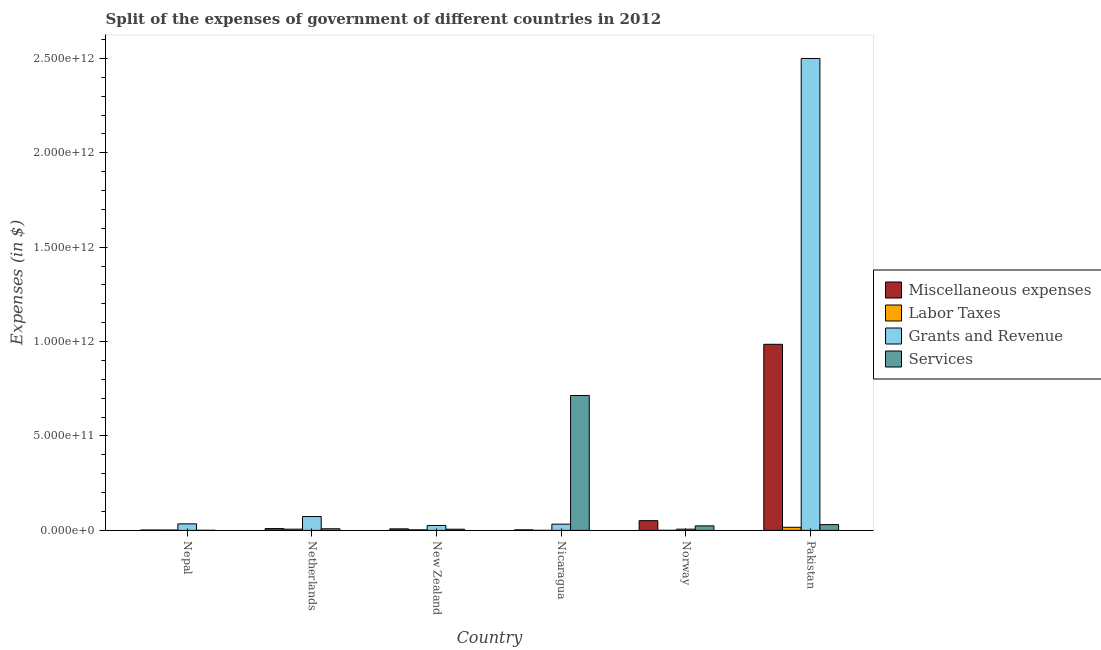How many different coloured bars are there?
Your response must be concise. 4. How many groups of bars are there?
Offer a very short reply. 6. How many bars are there on the 5th tick from the right?
Your response must be concise. 4. What is the label of the 6th group of bars from the left?
Provide a short and direct response. Pakistan. In how many cases, is the number of bars for a given country not equal to the number of legend labels?
Your response must be concise. 0. What is the amount spent on miscellaneous expenses in New Zealand?
Your answer should be very brief. 8.11e+09. Across all countries, what is the maximum amount spent on services?
Your answer should be very brief. 7.14e+11. Across all countries, what is the minimum amount spent on services?
Keep it short and to the point. 4.14e+08. In which country was the amount spent on grants and revenue maximum?
Offer a terse response. Pakistan. In which country was the amount spent on labor taxes minimum?
Keep it short and to the point. Nicaragua. What is the total amount spent on services in the graph?
Offer a very short reply. 7.84e+11. What is the difference between the amount spent on labor taxes in Netherlands and that in New Zealand?
Make the answer very short. 3.64e+09. What is the difference between the amount spent on grants and revenue in Nicaragua and the amount spent on labor taxes in Pakistan?
Your answer should be compact. 1.66e+1. What is the average amount spent on grants and revenue per country?
Offer a very short reply. 4.45e+11. What is the difference between the amount spent on labor taxes and amount spent on miscellaneous expenses in Nepal?
Offer a very short reply. -4.39e+07. What is the ratio of the amount spent on labor taxes in Nepal to that in Norway?
Keep it short and to the point. 7.44. Is the amount spent on labor taxes in New Zealand less than that in Pakistan?
Make the answer very short. Yes. What is the difference between the highest and the second highest amount spent on grants and revenue?
Offer a terse response. 2.43e+12. What is the difference between the highest and the lowest amount spent on miscellaneous expenses?
Make the answer very short. 9.84e+11. In how many countries, is the amount spent on miscellaneous expenses greater than the average amount spent on miscellaneous expenses taken over all countries?
Your answer should be very brief. 1. What does the 2nd bar from the left in New Zealand represents?
Give a very brief answer. Labor Taxes. What does the 2nd bar from the right in Netherlands represents?
Provide a succinct answer. Grants and Revenue. Is it the case that in every country, the sum of the amount spent on miscellaneous expenses and amount spent on labor taxes is greater than the amount spent on grants and revenue?
Offer a very short reply. No. Are all the bars in the graph horizontal?
Provide a succinct answer. No. How many countries are there in the graph?
Give a very brief answer. 6. What is the difference between two consecutive major ticks on the Y-axis?
Your response must be concise. 5.00e+11. Are the values on the major ticks of Y-axis written in scientific E-notation?
Ensure brevity in your answer.  Yes. Does the graph contain grids?
Offer a very short reply. No. Where does the legend appear in the graph?
Provide a short and direct response. Center right. How many legend labels are there?
Your response must be concise. 4. How are the legend labels stacked?
Ensure brevity in your answer.  Vertical. What is the title of the graph?
Make the answer very short. Split of the expenses of government of different countries in 2012. Does "Social Assistance" appear as one of the legend labels in the graph?
Ensure brevity in your answer.  No. What is the label or title of the X-axis?
Provide a succinct answer. Country. What is the label or title of the Y-axis?
Your answer should be compact. Expenses (in $). What is the Expenses (in $) in Miscellaneous expenses in Nepal?
Your answer should be very brief. 2.00e+09. What is the Expenses (in $) in Labor Taxes in Nepal?
Offer a terse response. 1.95e+09. What is the Expenses (in $) of Grants and Revenue in Nepal?
Offer a terse response. 3.46e+1. What is the Expenses (in $) of Services in Nepal?
Your answer should be compact. 4.14e+08. What is the Expenses (in $) of Miscellaneous expenses in Netherlands?
Ensure brevity in your answer.  9.59e+09. What is the Expenses (in $) of Labor Taxes in Netherlands?
Provide a succinct answer. 6.47e+09. What is the Expenses (in $) of Grants and Revenue in Netherlands?
Keep it short and to the point. 7.33e+1. What is the Expenses (in $) of Services in Netherlands?
Give a very brief answer. 8.57e+09. What is the Expenses (in $) of Miscellaneous expenses in New Zealand?
Keep it short and to the point. 8.11e+09. What is the Expenses (in $) in Labor Taxes in New Zealand?
Offer a terse response. 2.83e+09. What is the Expenses (in $) in Grants and Revenue in New Zealand?
Ensure brevity in your answer.  2.60e+1. What is the Expenses (in $) of Services in New Zealand?
Your response must be concise. 6.25e+09. What is the Expenses (in $) of Miscellaneous expenses in Nicaragua?
Offer a terse response. 2.83e+09. What is the Expenses (in $) in Labor Taxes in Nicaragua?
Your answer should be compact. 1.50e+08. What is the Expenses (in $) of Grants and Revenue in Nicaragua?
Your answer should be very brief. 3.30e+1. What is the Expenses (in $) of Services in Nicaragua?
Provide a succinct answer. 7.14e+11. What is the Expenses (in $) in Miscellaneous expenses in Norway?
Your answer should be compact. 5.16e+1. What is the Expenses (in $) of Labor Taxes in Norway?
Offer a terse response. 2.63e+08. What is the Expenses (in $) of Grants and Revenue in Norway?
Keep it short and to the point. 6.53e+09. What is the Expenses (in $) in Services in Norway?
Ensure brevity in your answer.  2.38e+1. What is the Expenses (in $) in Miscellaneous expenses in Pakistan?
Your answer should be very brief. 9.86e+11. What is the Expenses (in $) of Labor Taxes in Pakistan?
Offer a very short reply. 1.64e+1. What is the Expenses (in $) of Grants and Revenue in Pakistan?
Give a very brief answer. 2.50e+12. What is the Expenses (in $) in Services in Pakistan?
Ensure brevity in your answer.  3.05e+1. Across all countries, what is the maximum Expenses (in $) in Miscellaneous expenses?
Offer a terse response. 9.86e+11. Across all countries, what is the maximum Expenses (in $) of Labor Taxes?
Offer a very short reply. 1.64e+1. Across all countries, what is the maximum Expenses (in $) in Grants and Revenue?
Make the answer very short. 2.50e+12. Across all countries, what is the maximum Expenses (in $) of Services?
Your answer should be very brief. 7.14e+11. Across all countries, what is the minimum Expenses (in $) of Miscellaneous expenses?
Your answer should be very brief. 2.00e+09. Across all countries, what is the minimum Expenses (in $) of Labor Taxes?
Offer a very short reply. 1.50e+08. Across all countries, what is the minimum Expenses (in $) of Grants and Revenue?
Give a very brief answer. 6.53e+09. Across all countries, what is the minimum Expenses (in $) in Services?
Make the answer very short. 4.14e+08. What is the total Expenses (in $) in Miscellaneous expenses in the graph?
Provide a succinct answer. 1.06e+12. What is the total Expenses (in $) in Labor Taxes in the graph?
Ensure brevity in your answer.  2.81e+1. What is the total Expenses (in $) in Grants and Revenue in the graph?
Offer a terse response. 2.67e+12. What is the total Expenses (in $) in Services in the graph?
Keep it short and to the point. 7.84e+11. What is the difference between the Expenses (in $) in Miscellaneous expenses in Nepal and that in Netherlands?
Your answer should be very brief. -7.59e+09. What is the difference between the Expenses (in $) in Labor Taxes in Nepal and that in Netherlands?
Offer a terse response. -4.51e+09. What is the difference between the Expenses (in $) of Grants and Revenue in Nepal and that in Netherlands?
Provide a short and direct response. -3.88e+1. What is the difference between the Expenses (in $) in Services in Nepal and that in Netherlands?
Offer a terse response. -8.16e+09. What is the difference between the Expenses (in $) in Miscellaneous expenses in Nepal and that in New Zealand?
Offer a very short reply. -6.11e+09. What is the difference between the Expenses (in $) in Labor Taxes in Nepal and that in New Zealand?
Provide a succinct answer. -8.75e+08. What is the difference between the Expenses (in $) in Grants and Revenue in Nepal and that in New Zealand?
Ensure brevity in your answer.  8.54e+09. What is the difference between the Expenses (in $) in Services in Nepal and that in New Zealand?
Your answer should be very brief. -5.84e+09. What is the difference between the Expenses (in $) in Miscellaneous expenses in Nepal and that in Nicaragua?
Give a very brief answer. -8.30e+08. What is the difference between the Expenses (in $) in Labor Taxes in Nepal and that in Nicaragua?
Offer a terse response. 1.80e+09. What is the difference between the Expenses (in $) of Grants and Revenue in Nepal and that in Nicaragua?
Your answer should be very brief. 1.53e+09. What is the difference between the Expenses (in $) in Services in Nepal and that in Nicaragua?
Provide a short and direct response. -7.14e+11. What is the difference between the Expenses (in $) in Miscellaneous expenses in Nepal and that in Norway?
Provide a succinct answer. -4.96e+1. What is the difference between the Expenses (in $) in Labor Taxes in Nepal and that in Norway?
Make the answer very short. 1.69e+09. What is the difference between the Expenses (in $) in Grants and Revenue in Nepal and that in Norway?
Ensure brevity in your answer.  2.80e+1. What is the difference between the Expenses (in $) of Services in Nepal and that in Norway?
Keep it short and to the point. -2.34e+1. What is the difference between the Expenses (in $) in Miscellaneous expenses in Nepal and that in Pakistan?
Provide a succinct answer. -9.84e+11. What is the difference between the Expenses (in $) in Labor Taxes in Nepal and that in Pakistan?
Offer a very short reply. -1.45e+1. What is the difference between the Expenses (in $) of Grants and Revenue in Nepal and that in Pakistan?
Ensure brevity in your answer.  -2.46e+12. What is the difference between the Expenses (in $) in Services in Nepal and that in Pakistan?
Provide a succinct answer. -3.01e+1. What is the difference between the Expenses (in $) of Miscellaneous expenses in Netherlands and that in New Zealand?
Give a very brief answer. 1.48e+09. What is the difference between the Expenses (in $) of Labor Taxes in Netherlands and that in New Zealand?
Ensure brevity in your answer.  3.64e+09. What is the difference between the Expenses (in $) of Grants and Revenue in Netherlands and that in New Zealand?
Offer a terse response. 4.73e+1. What is the difference between the Expenses (in $) in Services in Netherlands and that in New Zealand?
Offer a very short reply. 2.32e+09. What is the difference between the Expenses (in $) in Miscellaneous expenses in Netherlands and that in Nicaragua?
Provide a succinct answer. 6.76e+09. What is the difference between the Expenses (in $) in Labor Taxes in Netherlands and that in Nicaragua?
Keep it short and to the point. 6.32e+09. What is the difference between the Expenses (in $) of Grants and Revenue in Netherlands and that in Nicaragua?
Give a very brief answer. 4.03e+1. What is the difference between the Expenses (in $) of Services in Netherlands and that in Nicaragua?
Keep it short and to the point. -7.06e+11. What is the difference between the Expenses (in $) in Miscellaneous expenses in Netherlands and that in Norway?
Ensure brevity in your answer.  -4.20e+1. What is the difference between the Expenses (in $) of Labor Taxes in Netherlands and that in Norway?
Give a very brief answer. 6.20e+09. What is the difference between the Expenses (in $) in Grants and Revenue in Netherlands and that in Norway?
Give a very brief answer. 6.68e+1. What is the difference between the Expenses (in $) in Services in Netherlands and that in Norway?
Provide a succinct answer. -1.53e+1. What is the difference between the Expenses (in $) of Miscellaneous expenses in Netherlands and that in Pakistan?
Your answer should be compact. -9.76e+11. What is the difference between the Expenses (in $) of Labor Taxes in Netherlands and that in Pakistan?
Provide a succinct answer. -9.98e+09. What is the difference between the Expenses (in $) of Grants and Revenue in Netherlands and that in Pakistan?
Your response must be concise. -2.43e+12. What is the difference between the Expenses (in $) of Services in Netherlands and that in Pakistan?
Your response must be concise. -2.19e+1. What is the difference between the Expenses (in $) in Miscellaneous expenses in New Zealand and that in Nicaragua?
Offer a terse response. 5.28e+09. What is the difference between the Expenses (in $) of Labor Taxes in New Zealand and that in Nicaragua?
Provide a short and direct response. 2.68e+09. What is the difference between the Expenses (in $) of Grants and Revenue in New Zealand and that in Nicaragua?
Provide a succinct answer. -7.01e+09. What is the difference between the Expenses (in $) of Services in New Zealand and that in Nicaragua?
Give a very brief answer. -7.08e+11. What is the difference between the Expenses (in $) in Miscellaneous expenses in New Zealand and that in Norway?
Your answer should be compact. -4.35e+1. What is the difference between the Expenses (in $) in Labor Taxes in New Zealand and that in Norway?
Your answer should be very brief. 2.57e+09. What is the difference between the Expenses (in $) of Grants and Revenue in New Zealand and that in Norway?
Keep it short and to the point. 1.95e+1. What is the difference between the Expenses (in $) in Services in New Zealand and that in Norway?
Keep it short and to the point. -1.76e+1. What is the difference between the Expenses (in $) in Miscellaneous expenses in New Zealand and that in Pakistan?
Provide a succinct answer. -9.77e+11. What is the difference between the Expenses (in $) in Labor Taxes in New Zealand and that in Pakistan?
Offer a very short reply. -1.36e+1. What is the difference between the Expenses (in $) of Grants and Revenue in New Zealand and that in Pakistan?
Keep it short and to the point. -2.47e+12. What is the difference between the Expenses (in $) of Services in New Zealand and that in Pakistan?
Your answer should be compact. -2.43e+1. What is the difference between the Expenses (in $) of Miscellaneous expenses in Nicaragua and that in Norway?
Offer a very short reply. -4.87e+1. What is the difference between the Expenses (in $) of Labor Taxes in Nicaragua and that in Norway?
Give a very brief answer. -1.13e+08. What is the difference between the Expenses (in $) of Grants and Revenue in Nicaragua and that in Norway?
Your response must be concise. 2.65e+1. What is the difference between the Expenses (in $) in Services in Nicaragua and that in Norway?
Your response must be concise. 6.91e+11. What is the difference between the Expenses (in $) of Miscellaneous expenses in Nicaragua and that in Pakistan?
Keep it short and to the point. -9.83e+11. What is the difference between the Expenses (in $) of Labor Taxes in Nicaragua and that in Pakistan?
Your response must be concise. -1.63e+1. What is the difference between the Expenses (in $) in Grants and Revenue in Nicaragua and that in Pakistan?
Make the answer very short. -2.47e+12. What is the difference between the Expenses (in $) in Services in Nicaragua and that in Pakistan?
Offer a very short reply. 6.84e+11. What is the difference between the Expenses (in $) in Miscellaneous expenses in Norway and that in Pakistan?
Give a very brief answer. -9.34e+11. What is the difference between the Expenses (in $) of Labor Taxes in Norway and that in Pakistan?
Your answer should be compact. -1.62e+1. What is the difference between the Expenses (in $) of Grants and Revenue in Norway and that in Pakistan?
Provide a short and direct response. -2.49e+12. What is the difference between the Expenses (in $) of Services in Norway and that in Pakistan?
Give a very brief answer. -6.68e+09. What is the difference between the Expenses (in $) of Miscellaneous expenses in Nepal and the Expenses (in $) of Labor Taxes in Netherlands?
Ensure brevity in your answer.  -4.47e+09. What is the difference between the Expenses (in $) of Miscellaneous expenses in Nepal and the Expenses (in $) of Grants and Revenue in Netherlands?
Provide a short and direct response. -7.13e+1. What is the difference between the Expenses (in $) in Miscellaneous expenses in Nepal and the Expenses (in $) in Services in Netherlands?
Your answer should be compact. -6.58e+09. What is the difference between the Expenses (in $) in Labor Taxes in Nepal and the Expenses (in $) in Grants and Revenue in Netherlands?
Offer a terse response. -7.14e+1. What is the difference between the Expenses (in $) of Labor Taxes in Nepal and the Expenses (in $) of Services in Netherlands?
Provide a succinct answer. -6.62e+09. What is the difference between the Expenses (in $) in Grants and Revenue in Nepal and the Expenses (in $) in Services in Netherlands?
Provide a succinct answer. 2.60e+1. What is the difference between the Expenses (in $) in Miscellaneous expenses in Nepal and the Expenses (in $) in Labor Taxes in New Zealand?
Keep it short and to the point. -8.31e+08. What is the difference between the Expenses (in $) of Miscellaneous expenses in Nepal and the Expenses (in $) of Grants and Revenue in New Zealand?
Provide a succinct answer. -2.40e+1. What is the difference between the Expenses (in $) in Miscellaneous expenses in Nepal and the Expenses (in $) in Services in New Zealand?
Offer a very short reply. -4.26e+09. What is the difference between the Expenses (in $) of Labor Taxes in Nepal and the Expenses (in $) of Grants and Revenue in New Zealand?
Your response must be concise. -2.41e+1. What is the difference between the Expenses (in $) in Labor Taxes in Nepal and the Expenses (in $) in Services in New Zealand?
Offer a very short reply. -4.30e+09. What is the difference between the Expenses (in $) of Grants and Revenue in Nepal and the Expenses (in $) of Services in New Zealand?
Provide a short and direct response. 2.83e+1. What is the difference between the Expenses (in $) in Miscellaneous expenses in Nepal and the Expenses (in $) in Labor Taxes in Nicaragua?
Give a very brief answer. 1.85e+09. What is the difference between the Expenses (in $) of Miscellaneous expenses in Nepal and the Expenses (in $) of Grants and Revenue in Nicaragua?
Ensure brevity in your answer.  -3.10e+1. What is the difference between the Expenses (in $) of Miscellaneous expenses in Nepal and the Expenses (in $) of Services in Nicaragua?
Provide a succinct answer. -7.12e+11. What is the difference between the Expenses (in $) of Labor Taxes in Nepal and the Expenses (in $) of Grants and Revenue in Nicaragua?
Offer a very short reply. -3.11e+1. What is the difference between the Expenses (in $) in Labor Taxes in Nepal and the Expenses (in $) in Services in Nicaragua?
Offer a terse response. -7.12e+11. What is the difference between the Expenses (in $) in Grants and Revenue in Nepal and the Expenses (in $) in Services in Nicaragua?
Ensure brevity in your answer.  -6.80e+11. What is the difference between the Expenses (in $) in Miscellaneous expenses in Nepal and the Expenses (in $) in Labor Taxes in Norway?
Your answer should be very brief. 1.73e+09. What is the difference between the Expenses (in $) of Miscellaneous expenses in Nepal and the Expenses (in $) of Grants and Revenue in Norway?
Keep it short and to the point. -4.53e+09. What is the difference between the Expenses (in $) in Miscellaneous expenses in Nepal and the Expenses (in $) in Services in Norway?
Your response must be concise. -2.18e+1. What is the difference between the Expenses (in $) in Labor Taxes in Nepal and the Expenses (in $) in Grants and Revenue in Norway?
Ensure brevity in your answer.  -4.57e+09. What is the difference between the Expenses (in $) in Labor Taxes in Nepal and the Expenses (in $) in Services in Norway?
Provide a short and direct response. -2.19e+1. What is the difference between the Expenses (in $) in Grants and Revenue in Nepal and the Expenses (in $) in Services in Norway?
Make the answer very short. 1.07e+1. What is the difference between the Expenses (in $) of Miscellaneous expenses in Nepal and the Expenses (in $) of Labor Taxes in Pakistan?
Offer a terse response. -1.45e+1. What is the difference between the Expenses (in $) of Miscellaneous expenses in Nepal and the Expenses (in $) of Grants and Revenue in Pakistan?
Make the answer very short. -2.50e+12. What is the difference between the Expenses (in $) in Miscellaneous expenses in Nepal and the Expenses (in $) in Services in Pakistan?
Keep it short and to the point. -2.85e+1. What is the difference between the Expenses (in $) in Labor Taxes in Nepal and the Expenses (in $) in Grants and Revenue in Pakistan?
Your response must be concise. -2.50e+12. What is the difference between the Expenses (in $) in Labor Taxes in Nepal and the Expenses (in $) in Services in Pakistan?
Make the answer very short. -2.86e+1. What is the difference between the Expenses (in $) in Grants and Revenue in Nepal and the Expenses (in $) in Services in Pakistan?
Offer a very short reply. 4.04e+09. What is the difference between the Expenses (in $) in Miscellaneous expenses in Netherlands and the Expenses (in $) in Labor Taxes in New Zealand?
Your response must be concise. 6.76e+09. What is the difference between the Expenses (in $) of Miscellaneous expenses in Netherlands and the Expenses (in $) of Grants and Revenue in New Zealand?
Keep it short and to the point. -1.64e+1. What is the difference between the Expenses (in $) of Miscellaneous expenses in Netherlands and the Expenses (in $) of Services in New Zealand?
Offer a very short reply. 3.33e+09. What is the difference between the Expenses (in $) in Labor Taxes in Netherlands and the Expenses (in $) in Grants and Revenue in New Zealand?
Give a very brief answer. -1.96e+1. What is the difference between the Expenses (in $) of Labor Taxes in Netherlands and the Expenses (in $) of Services in New Zealand?
Your answer should be compact. 2.15e+08. What is the difference between the Expenses (in $) of Grants and Revenue in Netherlands and the Expenses (in $) of Services in New Zealand?
Your answer should be very brief. 6.71e+1. What is the difference between the Expenses (in $) of Miscellaneous expenses in Netherlands and the Expenses (in $) of Labor Taxes in Nicaragua?
Make the answer very short. 9.44e+09. What is the difference between the Expenses (in $) in Miscellaneous expenses in Netherlands and the Expenses (in $) in Grants and Revenue in Nicaragua?
Give a very brief answer. -2.34e+1. What is the difference between the Expenses (in $) of Miscellaneous expenses in Netherlands and the Expenses (in $) of Services in Nicaragua?
Provide a short and direct response. -7.05e+11. What is the difference between the Expenses (in $) of Labor Taxes in Netherlands and the Expenses (in $) of Grants and Revenue in Nicaragua?
Provide a short and direct response. -2.66e+1. What is the difference between the Expenses (in $) of Labor Taxes in Netherlands and the Expenses (in $) of Services in Nicaragua?
Give a very brief answer. -7.08e+11. What is the difference between the Expenses (in $) in Grants and Revenue in Netherlands and the Expenses (in $) in Services in Nicaragua?
Your answer should be very brief. -6.41e+11. What is the difference between the Expenses (in $) in Miscellaneous expenses in Netherlands and the Expenses (in $) in Labor Taxes in Norway?
Provide a short and direct response. 9.32e+09. What is the difference between the Expenses (in $) of Miscellaneous expenses in Netherlands and the Expenses (in $) of Grants and Revenue in Norway?
Make the answer very short. 3.06e+09. What is the difference between the Expenses (in $) in Miscellaneous expenses in Netherlands and the Expenses (in $) in Services in Norway?
Make the answer very short. -1.43e+1. What is the difference between the Expenses (in $) in Labor Taxes in Netherlands and the Expenses (in $) in Grants and Revenue in Norway?
Offer a very short reply. -5.91e+07. What is the difference between the Expenses (in $) of Labor Taxes in Netherlands and the Expenses (in $) of Services in Norway?
Make the answer very short. -1.74e+1. What is the difference between the Expenses (in $) of Grants and Revenue in Netherlands and the Expenses (in $) of Services in Norway?
Make the answer very short. 4.95e+1. What is the difference between the Expenses (in $) in Miscellaneous expenses in Netherlands and the Expenses (in $) in Labor Taxes in Pakistan?
Provide a succinct answer. -6.86e+09. What is the difference between the Expenses (in $) in Miscellaneous expenses in Netherlands and the Expenses (in $) in Grants and Revenue in Pakistan?
Give a very brief answer. -2.49e+12. What is the difference between the Expenses (in $) in Miscellaneous expenses in Netherlands and the Expenses (in $) in Services in Pakistan?
Your response must be concise. -2.09e+1. What is the difference between the Expenses (in $) in Labor Taxes in Netherlands and the Expenses (in $) in Grants and Revenue in Pakistan?
Give a very brief answer. -2.49e+12. What is the difference between the Expenses (in $) of Labor Taxes in Netherlands and the Expenses (in $) of Services in Pakistan?
Your response must be concise. -2.41e+1. What is the difference between the Expenses (in $) of Grants and Revenue in Netherlands and the Expenses (in $) of Services in Pakistan?
Give a very brief answer. 4.28e+1. What is the difference between the Expenses (in $) of Miscellaneous expenses in New Zealand and the Expenses (in $) of Labor Taxes in Nicaragua?
Offer a very short reply. 7.96e+09. What is the difference between the Expenses (in $) in Miscellaneous expenses in New Zealand and the Expenses (in $) in Grants and Revenue in Nicaragua?
Ensure brevity in your answer.  -2.49e+1. What is the difference between the Expenses (in $) of Miscellaneous expenses in New Zealand and the Expenses (in $) of Services in Nicaragua?
Provide a succinct answer. -7.06e+11. What is the difference between the Expenses (in $) of Labor Taxes in New Zealand and the Expenses (in $) of Grants and Revenue in Nicaragua?
Provide a succinct answer. -3.02e+1. What is the difference between the Expenses (in $) of Labor Taxes in New Zealand and the Expenses (in $) of Services in Nicaragua?
Offer a terse response. -7.12e+11. What is the difference between the Expenses (in $) of Grants and Revenue in New Zealand and the Expenses (in $) of Services in Nicaragua?
Your response must be concise. -6.88e+11. What is the difference between the Expenses (in $) in Miscellaneous expenses in New Zealand and the Expenses (in $) in Labor Taxes in Norway?
Your answer should be very brief. 7.85e+09. What is the difference between the Expenses (in $) of Miscellaneous expenses in New Zealand and the Expenses (in $) of Grants and Revenue in Norway?
Give a very brief answer. 1.58e+09. What is the difference between the Expenses (in $) in Miscellaneous expenses in New Zealand and the Expenses (in $) in Services in Norway?
Keep it short and to the point. -1.57e+1. What is the difference between the Expenses (in $) in Labor Taxes in New Zealand and the Expenses (in $) in Grants and Revenue in Norway?
Your answer should be compact. -3.70e+09. What is the difference between the Expenses (in $) of Labor Taxes in New Zealand and the Expenses (in $) of Services in Norway?
Give a very brief answer. -2.10e+1. What is the difference between the Expenses (in $) in Grants and Revenue in New Zealand and the Expenses (in $) in Services in Norway?
Offer a very short reply. 2.18e+09. What is the difference between the Expenses (in $) in Miscellaneous expenses in New Zealand and the Expenses (in $) in Labor Taxes in Pakistan?
Provide a succinct answer. -8.34e+09. What is the difference between the Expenses (in $) in Miscellaneous expenses in New Zealand and the Expenses (in $) in Grants and Revenue in Pakistan?
Ensure brevity in your answer.  -2.49e+12. What is the difference between the Expenses (in $) in Miscellaneous expenses in New Zealand and the Expenses (in $) in Services in Pakistan?
Your answer should be very brief. -2.24e+1. What is the difference between the Expenses (in $) of Labor Taxes in New Zealand and the Expenses (in $) of Grants and Revenue in Pakistan?
Provide a succinct answer. -2.50e+12. What is the difference between the Expenses (in $) of Labor Taxes in New Zealand and the Expenses (in $) of Services in Pakistan?
Provide a succinct answer. -2.77e+1. What is the difference between the Expenses (in $) of Grants and Revenue in New Zealand and the Expenses (in $) of Services in Pakistan?
Your answer should be compact. -4.50e+09. What is the difference between the Expenses (in $) of Miscellaneous expenses in Nicaragua and the Expenses (in $) of Labor Taxes in Norway?
Provide a succinct answer. 2.56e+09. What is the difference between the Expenses (in $) of Miscellaneous expenses in Nicaragua and the Expenses (in $) of Grants and Revenue in Norway?
Provide a short and direct response. -3.70e+09. What is the difference between the Expenses (in $) of Miscellaneous expenses in Nicaragua and the Expenses (in $) of Services in Norway?
Make the answer very short. -2.10e+1. What is the difference between the Expenses (in $) of Labor Taxes in Nicaragua and the Expenses (in $) of Grants and Revenue in Norway?
Offer a very short reply. -6.38e+09. What is the difference between the Expenses (in $) of Labor Taxes in Nicaragua and the Expenses (in $) of Services in Norway?
Provide a succinct answer. -2.37e+1. What is the difference between the Expenses (in $) of Grants and Revenue in Nicaragua and the Expenses (in $) of Services in Norway?
Your response must be concise. 9.19e+09. What is the difference between the Expenses (in $) of Miscellaneous expenses in Nicaragua and the Expenses (in $) of Labor Taxes in Pakistan?
Make the answer very short. -1.36e+1. What is the difference between the Expenses (in $) in Miscellaneous expenses in Nicaragua and the Expenses (in $) in Grants and Revenue in Pakistan?
Ensure brevity in your answer.  -2.50e+12. What is the difference between the Expenses (in $) of Miscellaneous expenses in Nicaragua and the Expenses (in $) of Services in Pakistan?
Offer a terse response. -2.77e+1. What is the difference between the Expenses (in $) in Labor Taxes in Nicaragua and the Expenses (in $) in Grants and Revenue in Pakistan?
Your response must be concise. -2.50e+12. What is the difference between the Expenses (in $) in Labor Taxes in Nicaragua and the Expenses (in $) in Services in Pakistan?
Provide a succinct answer. -3.04e+1. What is the difference between the Expenses (in $) of Grants and Revenue in Nicaragua and the Expenses (in $) of Services in Pakistan?
Give a very brief answer. 2.51e+09. What is the difference between the Expenses (in $) in Miscellaneous expenses in Norway and the Expenses (in $) in Labor Taxes in Pakistan?
Make the answer very short. 3.51e+1. What is the difference between the Expenses (in $) of Miscellaneous expenses in Norway and the Expenses (in $) of Grants and Revenue in Pakistan?
Make the answer very short. -2.45e+12. What is the difference between the Expenses (in $) of Miscellaneous expenses in Norway and the Expenses (in $) of Services in Pakistan?
Offer a terse response. 2.10e+1. What is the difference between the Expenses (in $) of Labor Taxes in Norway and the Expenses (in $) of Grants and Revenue in Pakistan?
Ensure brevity in your answer.  -2.50e+12. What is the difference between the Expenses (in $) of Labor Taxes in Norway and the Expenses (in $) of Services in Pakistan?
Provide a short and direct response. -3.03e+1. What is the difference between the Expenses (in $) in Grants and Revenue in Norway and the Expenses (in $) in Services in Pakistan?
Provide a succinct answer. -2.40e+1. What is the average Expenses (in $) in Miscellaneous expenses per country?
Ensure brevity in your answer.  1.77e+11. What is the average Expenses (in $) in Labor Taxes per country?
Ensure brevity in your answer.  4.69e+09. What is the average Expenses (in $) of Grants and Revenue per country?
Ensure brevity in your answer.  4.45e+11. What is the average Expenses (in $) in Services per country?
Offer a terse response. 1.31e+11. What is the difference between the Expenses (in $) of Miscellaneous expenses and Expenses (in $) of Labor Taxes in Nepal?
Ensure brevity in your answer.  4.39e+07. What is the difference between the Expenses (in $) in Miscellaneous expenses and Expenses (in $) in Grants and Revenue in Nepal?
Your answer should be compact. -3.26e+1. What is the difference between the Expenses (in $) in Miscellaneous expenses and Expenses (in $) in Services in Nepal?
Make the answer very short. 1.58e+09. What is the difference between the Expenses (in $) of Labor Taxes and Expenses (in $) of Grants and Revenue in Nepal?
Your response must be concise. -3.26e+1. What is the difference between the Expenses (in $) in Labor Taxes and Expenses (in $) in Services in Nepal?
Your answer should be compact. 1.54e+09. What is the difference between the Expenses (in $) in Grants and Revenue and Expenses (in $) in Services in Nepal?
Your answer should be compact. 3.41e+1. What is the difference between the Expenses (in $) of Miscellaneous expenses and Expenses (in $) of Labor Taxes in Netherlands?
Your response must be concise. 3.12e+09. What is the difference between the Expenses (in $) in Miscellaneous expenses and Expenses (in $) in Grants and Revenue in Netherlands?
Ensure brevity in your answer.  -6.38e+1. What is the difference between the Expenses (in $) in Miscellaneous expenses and Expenses (in $) in Services in Netherlands?
Give a very brief answer. 1.01e+09. What is the difference between the Expenses (in $) of Labor Taxes and Expenses (in $) of Grants and Revenue in Netherlands?
Provide a short and direct response. -6.69e+1. What is the difference between the Expenses (in $) of Labor Taxes and Expenses (in $) of Services in Netherlands?
Make the answer very short. -2.11e+09. What is the difference between the Expenses (in $) in Grants and Revenue and Expenses (in $) in Services in Netherlands?
Make the answer very short. 6.48e+1. What is the difference between the Expenses (in $) of Miscellaneous expenses and Expenses (in $) of Labor Taxes in New Zealand?
Offer a terse response. 5.28e+09. What is the difference between the Expenses (in $) in Miscellaneous expenses and Expenses (in $) in Grants and Revenue in New Zealand?
Offer a very short reply. -1.79e+1. What is the difference between the Expenses (in $) in Miscellaneous expenses and Expenses (in $) in Services in New Zealand?
Make the answer very short. 1.86e+09. What is the difference between the Expenses (in $) of Labor Taxes and Expenses (in $) of Grants and Revenue in New Zealand?
Your answer should be compact. -2.32e+1. What is the difference between the Expenses (in $) of Labor Taxes and Expenses (in $) of Services in New Zealand?
Your response must be concise. -3.42e+09. What is the difference between the Expenses (in $) of Grants and Revenue and Expenses (in $) of Services in New Zealand?
Give a very brief answer. 1.98e+1. What is the difference between the Expenses (in $) in Miscellaneous expenses and Expenses (in $) in Labor Taxes in Nicaragua?
Offer a very short reply. 2.68e+09. What is the difference between the Expenses (in $) in Miscellaneous expenses and Expenses (in $) in Grants and Revenue in Nicaragua?
Offer a very short reply. -3.02e+1. What is the difference between the Expenses (in $) in Miscellaneous expenses and Expenses (in $) in Services in Nicaragua?
Ensure brevity in your answer.  -7.12e+11. What is the difference between the Expenses (in $) in Labor Taxes and Expenses (in $) in Grants and Revenue in Nicaragua?
Ensure brevity in your answer.  -3.29e+1. What is the difference between the Expenses (in $) in Labor Taxes and Expenses (in $) in Services in Nicaragua?
Your response must be concise. -7.14e+11. What is the difference between the Expenses (in $) of Grants and Revenue and Expenses (in $) of Services in Nicaragua?
Keep it short and to the point. -6.81e+11. What is the difference between the Expenses (in $) in Miscellaneous expenses and Expenses (in $) in Labor Taxes in Norway?
Provide a succinct answer. 5.13e+1. What is the difference between the Expenses (in $) in Miscellaneous expenses and Expenses (in $) in Grants and Revenue in Norway?
Your response must be concise. 4.50e+1. What is the difference between the Expenses (in $) in Miscellaneous expenses and Expenses (in $) in Services in Norway?
Provide a succinct answer. 2.77e+1. What is the difference between the Expenses (in $) of Labor Taxes and Expenses (in $) of Grants and Revenue in Norway?
Your answer should be compact. -6.26e+09. What is the difference between the Expenses (in $) in Labor Taxes and Expenses (in $) in Services in Norway?
Give a very brief answer. -2.36e+1. What is the difference between the Expenses (in $) of Grants and Revenue and Expenses (in $) of Services in Norway?
Offer a terse response. -1.73e+1. What is the difference between the Expenses (in $) of Miscellaneous expenses and Expenses (in $) of Labor Taxes in Pakistan?
Offer a terse response. 9.69e+11. What is the difference between the Expenses (in $) in Miscellaneous expenses and Expenses (in $) in Grants and Revenue in Pakistan?
Your answer should be very brief. -1.51e+12. What is the difference between the Expenses (in $) in Miscellaneous expenses and Expenses (in $) in Services in Pakistan?
Offer a terse response. 9.55e+11. What is the difference between the Expenses (in $) of Labor Taxes and Expenses (in $) of Grants and Revenue in Pakistan?
Ensure brevity in your answer.  -2.48e+12. What is the difference between the Expenses (in $) of Labor Taxes and Expenses (in $) of Services in Pakistan?
Provide a short and direct response. -1.41e+1. What is the difference between the Expenses (in $) of Grants and Revenue and Expenses (in $) of Services in Pakistan?
Offer a very short reply. 2.47e+12. What is the ratio of the Expenses (in $) in Miscellaneous expenses in Nepal to that in Netherlands?
Provide a succinct answer. 0.21. What is the ratio of the Expenses (in $) of Labor Taxes in Nepal to that in Netherlands?
Ensure brevity in your answer.  0.3. What is the ratio of the Expenses (in $) in Grants and Revenue in Nepal to that in Netherlands?
Ensure brevity in your answer.  0.47. What is the ratio of the Expenses (in $) of Services in Nepal to that in Netherlands?
Provide a succinct answer. 0.05. What is the ratio of the Expenses (in $) in Miscellaneous expenses in Nepal to that in New Zealand?
Your answer should be compact. 0.25. What is the ratio of the Expenses (in $) of Labor Taxes in Nepal to that in New Zealand?
Your answer should be very brief. 0.69. What is the ratio of the Expenses (in $) in Grants and Revenue in Nepal to that in New Zealand?
Offer a terse response. 1.33. What is the ratio of the Expenses (in $) of Services in Nepal to that in New Zealand?
Provide a short and direct response. 0.07. What is the ratio of the Expenses (in $) in Miscellaneous expenses in Nepal to that in Nicaragua?
Offer a terse response. 0.71. What is the ratio of the Expenses (in $) of Labor Taxes in Nepal to that in Nicaragua?
Provide a succinct answer. 13.02. What is the ratio of the Expenses (in $) of Grants and Revenue in Nepal to that in Nicaragua?
Your answer should be very brief. 1.05. What is the ratio of the Expenses (in $) of Services in Nepal to that in Nicaragua?
Your response must be concise. 0. What is the ratio of the Expenses (in $) of Miscellaneous expenses in Nepal to that in Norway?
Your answer should be compact. 0.04. What is the ratio of the Expenses (in $) of Labor Taxes in Nepal to that in Norway?
Keep it short and to the point. 7.44. What is the ratio of the Expenses (in $) of Grants and Revenue in Nepal to that in Norway?
Your answer should be very brief. 5.3. What is the ratio of the Expenses (in $) of Services in Nepal to that in Norway?
Provide a succinct answer. 0.02. What is the ratio of the Expenses (in $) of Miscellaneous expenses in Nepal to that in Pakistan?
Your response must be concise. 0. What is the ratio of the Expenses (in $) of Labor Taxes in Nepal to that in Pakistan?
Provide a short and direct response. 0.12. What is the ratio of the Expenses (in $) of Grants and Revenue in Nepal to that in Pakistan?
Give a very brief answer. 0.01. What is the ratio of the Expenses (in $) in Services in Nepal to that in Pakistan?
Give a very brief answer. 0.01. What is the ratio of the Expenses (in $) in Miscellaneous expenses in Netherlands to that in New Zealand?
Your answer should be compact. 1.18. What is the ratio of the Expenses (in $) of Labor Taxes in Netherlands to that in New Zealand?
Your response must be concise. 2.29. What is the ratio of the Expenses (in $) in Grants and Revenue in Netherlands to that in New Zealand?
Your answer should be compact. 2.82. What is the ratio of the Expenses (in $) of Services in Netherlands to that in New Zealand?
Give a very brief answer. 1.37. What is the ratio of the Expenses (in $) of Miscellaneous expenses in Netherlands to that in Nicaragua?
Give a very brief answer. 3.39. What is the ratio of the Expenses (in $) in Labor Taxes in Netherlands to that in Nicaragua?
Make the answer very short. 43.12. What is the ratio of the Expenses (in $) of Grants and Revenue in Netherlands to that in Nicaragua?
Offer a terse response. 2.22. What is the ratio of the Expenses (in $) of Services in Netherlands to that in Nicaragua?
Your answer should be compact. 0.01. What is the ratio of the Expenses (in $) of Miscellaneous expenses in Netherlands to that in Norway?
Offer a terse response. 0.19. What is the ratio of the Expenses (in $) of Labor Taxes in Netherlands to that in Norway?
Give a very brief answer. 24.63. What is the ratio of the Expenses (in $) in Grants and Revenue in Netherlands to that in Norway?
Give a very brief answer. 11.24. What is the ratio of the Expenses (in $) in Services in Netherlands to that in Norway?
Keep it short and to the point. 0.36. What is the ratio of the Expenses (in $) of Miscellaneous expenses in Netherlands to that in Pakistan?
Offer a terse response. 0.01. What is the ratio of the Expenses (in $) in Labor Taxes in Netherlands to that in Pakistan?
Provide a succinct answer. 0.39. What is the ratio of the Expenses (in $) in Grants and Revenue in Netherlands to that in Pakistan?
Offer a very short reply. 0.03. What is the ratio of the Expenses (in $) in Services in Netherlands to that in Pakistan?
Provide a short and direct response. 0.28. What is the ratio of the Expenses (in $) of Miscellaneous expenses in New Zealand to that in Nicaragua?
Make the answer very short. 2.87. What is the ratio of the Expenses (in $) of Labor Taxes in New Zealand to that in Nicaragua?
Give a very brief answer. 18.85. What is the ratio of the Expenses (in $) in Grants and Revenue in New Zealand to that in Nicaragua?
Give a very brief answer. 0.79. What is the ratio of the Expenses (in $) in Services in New Zealand to that in Nicaragua?
Provide a short and direct response. 0.01. What is the ratio of the Expenses (in $) in Miscellaneous expenses in New Zealand to that in Norway?
Offer a very short reply. 0.16. What is the ratio of the Expenses (in $) of Labor Taxes in New Zealand to that in Norway?
Your response must be concise. 10.77. What is the ratio of the Expenses (in $) in Grants and Revenue in New Zealand to that in Norway?
Provide a short and direct response. 3.99. What is the ratio of the Expenses (in $) in Services in New Zealand to that in Norway?
Provide a succinct answer. 0.26. What is the ratio of the Expenses (in $) in Miscellaneous expenses in New Zealand to that in Pakistan?
Keep it short and to the point. 0.01. What is the ratio of the Expenses (in $) of Labor Taxes in New Zealand to that in Pakistan?
Your response must be concise. 0.17. What is the ratio of the Expenses (in $) of Grants and Revenue in New Zealand to that in Pakistan?
Your answer should be compact. 0.01. What is the ratio of the Expenses (in $) in Services in New Zealand to that in Pakistan?
Offer a very short reply. 0.2. What is the ratio of the Expenses (in $) in Miscellaneous expenses in Nicaragua to that in Norway?
Keep it short and to the point. 0.05. What is the ratio of the Expenses (in $) of Labor Taxes in Nicaragua to that in Norway?
Provide a succinct answer. 0.57. What is the ratio of the Expenses (in $) of Grants and Revenue in Nicaragua to that in Norway?
Give a very brief answer. 5.06. What is the ratio of the Expenses (in $) in Services in Nicaragua to that in Norway?
Offer a terse response. 29.96. What is the ratio of the Expenses (in $) in Miscellaneous expenses in Nicaragua to that in Pakistan?
Keep it short and to the point. 0. What is the ratio of the Expenses (in $) in Labor Taxes in Nicaragua to that in Pakistan?
Your response must be concise. 0.01. What is the ratio of the Expenses (in $) of Grants and Revenue in Nicaragua to that in Pakistan?
Your response must be concise. 0.01. What is the ratio of the Expenses (in $) of Services in Nicaragua to that in Pakistan?
Offer a terse response. 23.41. What is the ratio of the Expenses (in $) of Miscellaneous expenses in Norway to that in Pakistan?
Keep it short and to the point. 0.05. What is the ratio of the Expenses (in $) of Labor Taxes in Norway to that in Pakistan?
Offer a terse response. 0.02. What is the ratio of the Expenses (in $) of Grants and Revenue in Norway to that in Pakistan?
Provide a short and direct response. 0. What is the ratio of the Expenses (in $) of Services in Norway to that in Pakistan?
Provide a short and direct response. 0.78. What is the difference between the highest and the second highest Expenses (in $) in Miscellaneous expenses?
Give a very brief answer. 9.34e+11. What is the difference between the highest and the second highest Expenses (in $) in Labor Taxes?
Give a very brief answer. 9.98e+09. What is the difference between the highest and the second highest Expenses (in $) of Grants and Revenue?
Your answer should be very brief. 2.43e+12. What is the difference between the highest and the second highest Expenses (in $) of Services?
Ensure brevity in your answer.  6.84e+11. What is the difference between the highest and the lowest Expenses (in $) in Miscellaneous expenses?
Your answer should be very brief. 9.84e+11. What is the difference between the highest and the lowest Expenses (in $) in Labor Taxes?
Your response must be concise. 1.63e+1. What is the difference between the highest and the lowest Expenses (in $) of Grants and Revenue?
Keep it short and to the point. 2.49e+12. What is the difference between the highest and the lowest Expenses (in $) of Services?
Make the answer very short. 7.14e+11. 